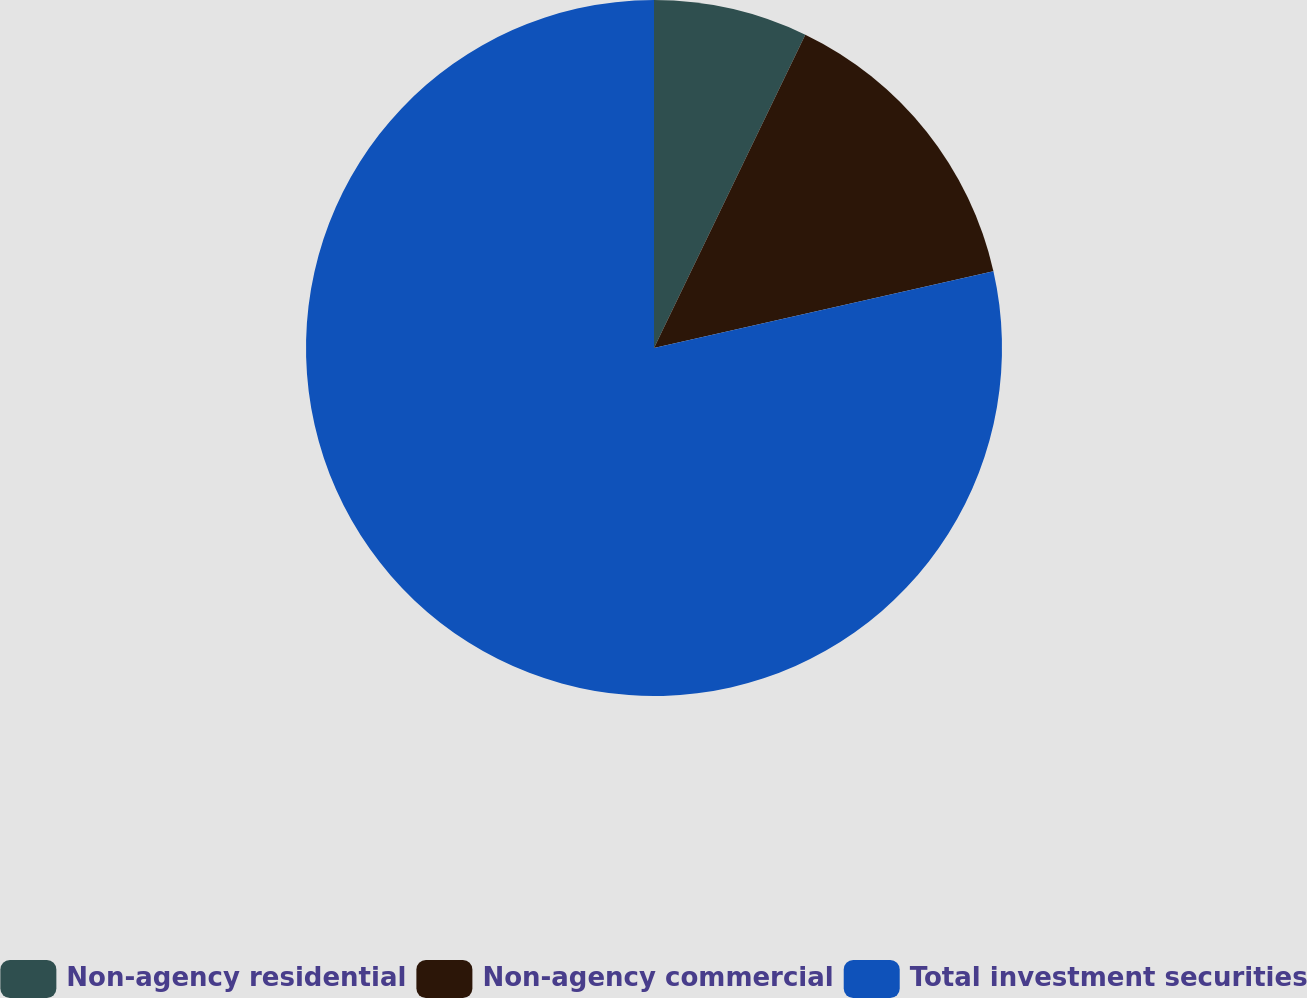Convert chart. <chart><loc_0><loc_0><loc_500><loc_500><pie_chart><fcel>Non-agency residential<fcel>Non-agency commercial<fcel>Total investment securities<nl><fcel>7.16%<fcel>14.3%<fcel>78.54%<nl></chart> 